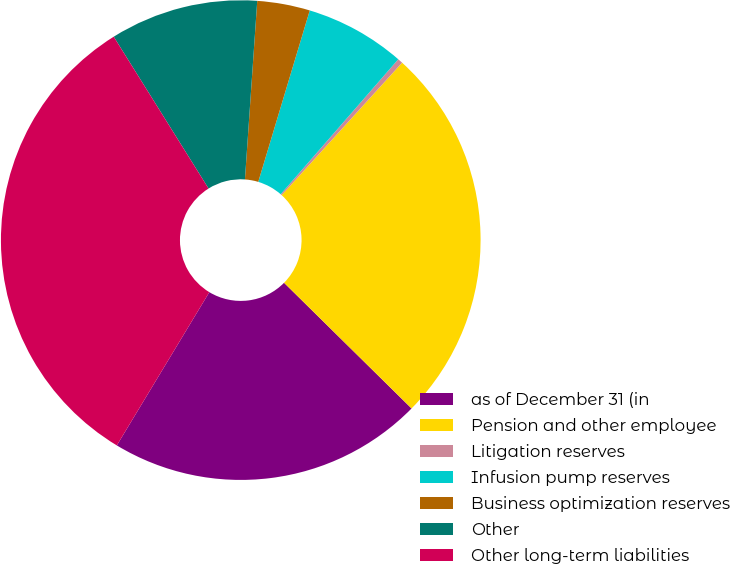<chart> <loc_0><loc_0><loc_500><loc_500><pie_chart><fcel>as of December 31 (in<fcel>Pension and other employee<fcel>Litigation reserves<fcel>Infusion pump reserves<fcel>Business optimization reserves<fcel>Other<fcel>Other long-term liabilities<nl><fcel>21.26%<fcel>25.64%<fcel>0.34%<fcel>6.76%<fcel>3.55%<fcel>9.98%<fcel>32.47%<nl></chart> 